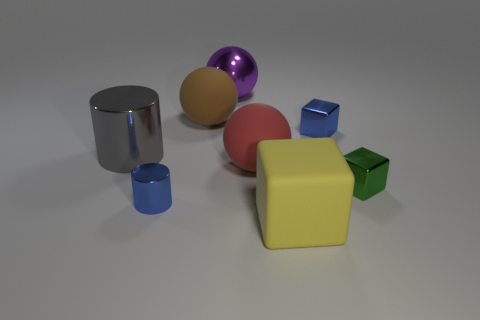Does the large purple sphere have the same material as the tiny green thing?
Your answer should be compact. Yes. What number of big rubber spheres are right of the purple metallic ball?
Offer a terse response. 1. There is a sphere that is right of the big brown rubber thing and in front of the shiny ball; what material is it?
Your answer should be very brief. Rubber. What number of yellow blocks are the same size as the blue block?
Offer a terse response. 0. What color is the block that is to the right of the blue metallic object that is to the right of the yellow cube?
Your answer should be compact. Green. Are there any tiny brown matte objects?
Provide a short and direct response. No. Is the large purple metal object the same shape as the yellow thing?
Your response must be concise. No. What size is the shiny block that is the same color as the small cylinder?
Your answer should be compact. Small. There is a tiny blue metallic thing that is behind the large gray metallic cylinder; how many big gray metal cylinders are behind it?
Your answer should be very brief. 0. What number of small metal things are both on the left side of the rubber block and on the right side of the big purple thing?
Offer a terse response. 0. 